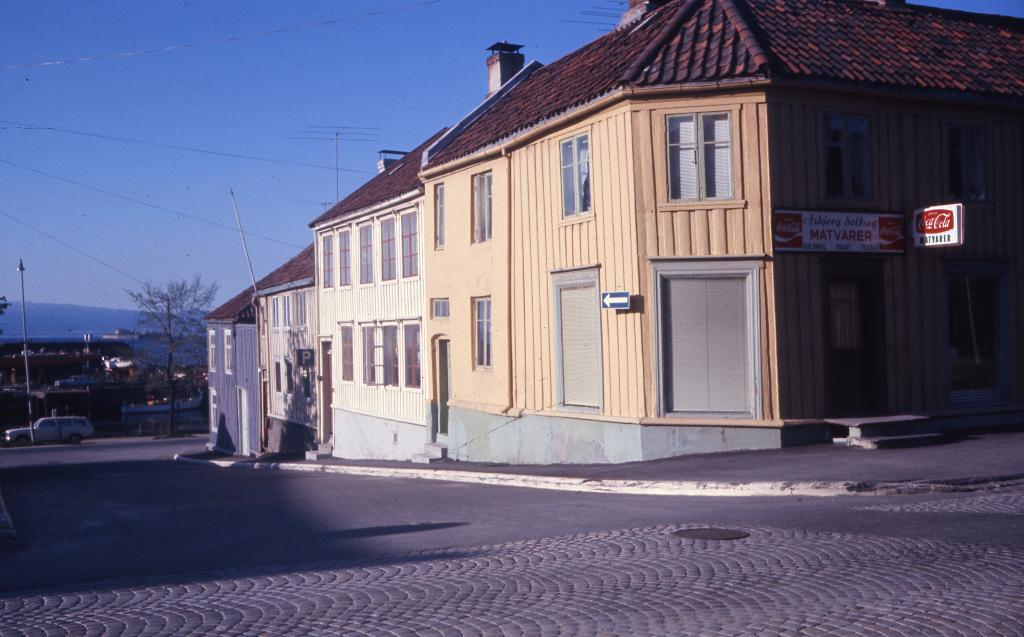What is: What type of structures are located in the middle of the picture? There are houses in the middle of the picture. What is in front of the houses? There is a road in front of the houses. What can be seen in the background of the picture? The sky is visible in the background of the picture. What type of afterthought is expressed by the actor in the image? There is no actor present in the image, and therefore no afterthought can be observed. 